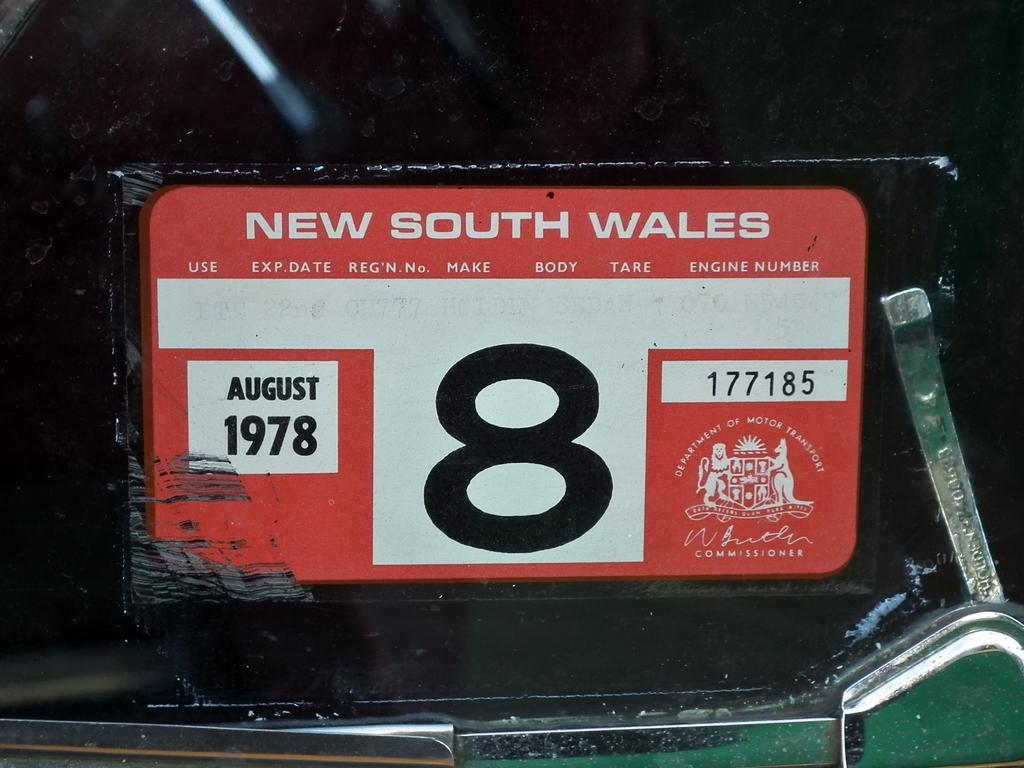Provide a one-sentence caption for the provided image. A license plates from New South Wales with the expiration date of August 1978. 